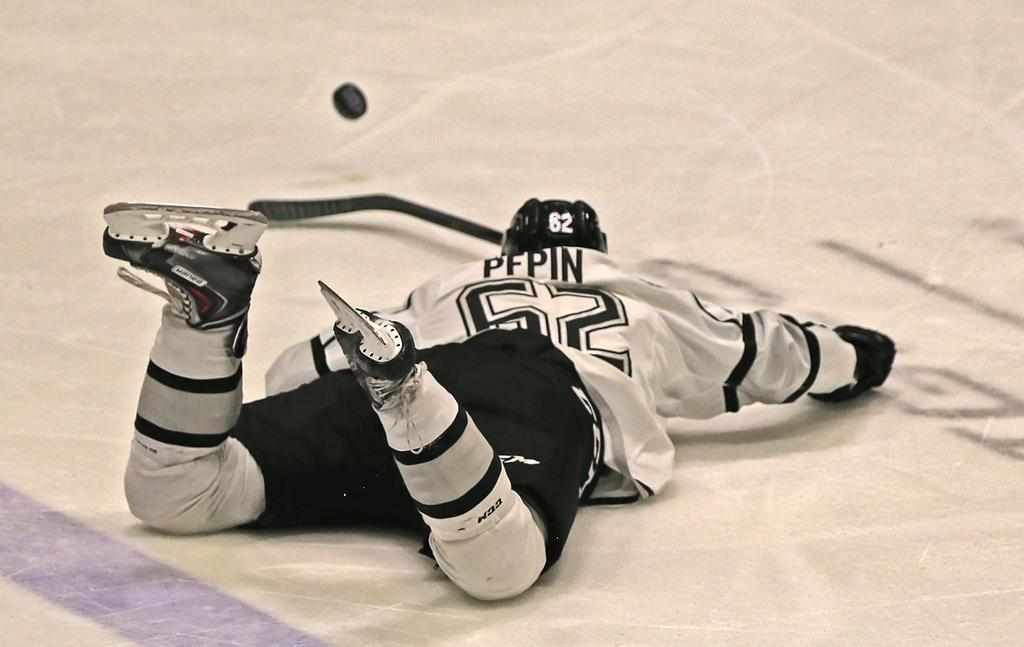<image>
Describe the image concisely. M hockey player on the ice with the name PEPIN on his back jersey. 